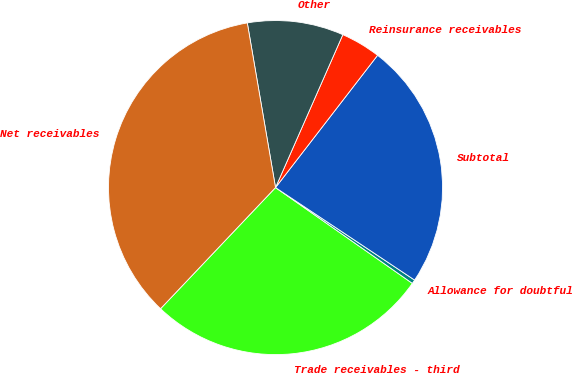Convert chart to OTSL. <chart><loc_0><loc_0><loc_500><loc_500><pie_chart><fcel>Trade receivables - third<fcel>Allowance for doubtful<fcel>Subtotal<fcel>Reinsurance receivables<fcel>Other<fcel>Net receivables<nl><fcel>27.36%<fcel>0.38%<fcel>23.88%<fcel>3.86%<fcel>9.3%<fcel>35.21%<nl></chart> 